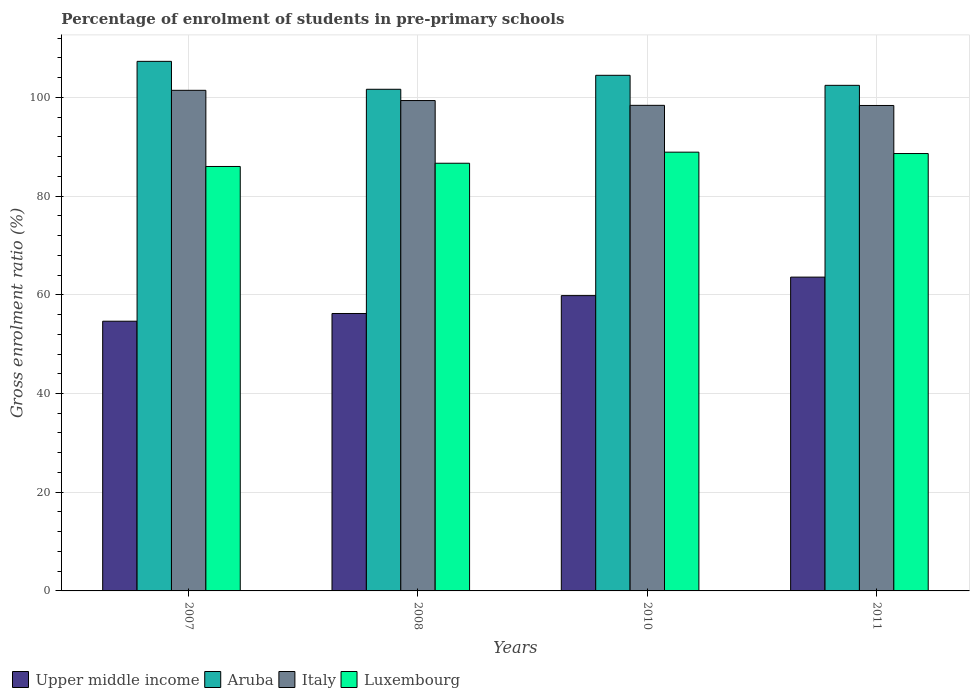Are the number of bars on each tick of the X-axis equal?
Provide a succinct answer. Yes. How many bars are there on the 2nd tick from the left?
Your answer should be very brief. 4. How many bars are there on the 4th tick from the right?
Your answer should be very brief. 4. What is the label of the 3rd group of bars from the left?
Provide a succinct answer. 2010. What is the percentage of students enrolled in pre-primary schools in Italy in 2008?
Give a very brief answer. 99.35. Across all years, what is the maximum percentage of students enrolled in pre-primary schools in Italy?
Offer a terse response. 101.42. Across all years, what is the minimum percentage of students enrolled in pre-primary schools in Upper middle income?
Provide a succinct answer. 54.64. What is the total percentage of students enrolled in pre-primary schools in Italy in the graph?
Your answer should be very brief. 397.5. What is the difference between the percentage of students enrolled in pre-primary schools in Luxembourg in 2008 and that in 2010?
Your response must be concise. -2.25. What is the difference between the percentage of students enrolled in pre-primary schools in Upper middle income in 2008 and the percentage of students enrolled in pre-primary schools in Aruba in 2007?
Provide a short and direct response. -51.08. What is the average percentage of students enrolled in pre-primary schools in Italy per year?
Offer a very short reply. 99.38. In the year 2010, what is the difference between the percentage of students enrolled in pre-primary schools in Italy and percentage of students enrolled in pre-primary schools in Luxembourg?
Make the answer very short. 9.49. In how many years, is the percentage of students enrolled in pre-primary schools in Italy greater than 24 %?
Your answer should be very brief. 4. What is the ratio of the percentage of students enrolled in pre-primary schools in Upper middle income in 2010 to that in 2011?
Provide a short and direct response. 0.94. What is the difference between the highest and the second highest percentage of students enrolled in pre-primary schools in Luxembourg?
Keep it short and to the point. 0.28. What is the difference between the highest and the lowest percentage of students enrolled in pre-primary schools in Italy?
Ensure brevity in your answer.  3.07. In how many years, is the percentage of students enrolled in pre-primary schools in Luxembourg greater than the average percentage of students enrolled in pre-primary schools in Luxembourg taken over all years?
Ensure brevity in your answer.  2. Is it the case that in every year, the sum of the percentage of students enrolled in pre-primary schools in Aruba and percentage of students enrolled in pre-primary schools in Italy is greater than the sum of percentage of students enrolled in pre-primary schools in Luxembourg and percentage of students enrolled in pre-primary schools in Upper middle income?
Keep it short and to the point. Yes. What does the 2nd bar from the left in 2010 represents?
Your answer should be very brief. Aruba. What does the 3rd bar from the right in 2008 represents?
Offer a terse response. Aruba. Is it the case that in every year, the sum of the percentage of students enrolled in pre-primary schools in Aruba and percentage of students enrolled in pre-primary schools in Italy is greater than the percentage of students enrolled in pre-primary schools in Luxembourg?
Your response must be concise. Yes. Are the values on the major ticks of Y-axis written in scientific E-notation?
Offer a very short reply. No. Does the graph contain grids?
Your response must be concise. Yes. How many legend labels are there?
Provide a short and direct response. 4. How are the legend labels stacked?
Your response must be concise. Horizontal. What is the title of the graph?
Give a very brief answer. Percentage of enrolment of students in pre-primary schools. What is the label or title of the X-axis?
Your answer should be very brief. Years. What is the Gross enrolment ratio (%) in Upper middle income in 2007?
Provide a succinct answer. 54.64. What is the Gross enrolment ratio (%) of Aruba in 2007?
Make the answer very short. 107.29. What is the Gross enrolment ratio (%) of Italy in 2007?
Your response must be concise. 101.42. What is the Gross enrolment ratio (%) of Luxembourg in 2007?
Your answer should be compact. 85.99. What is the Gross enrolment ratio (%) in Upper middle income in 2008?
Keep it short and to the point. 56.21. What is the Gross enrolment ratio (%) of Aruba in 2008?
Ensure brevity in your answer.  101.63. What is the Gross enrolment ratio (%) of Italy in 2008?
Provide a succinct answer. 99.35. What is the Gross enrolment ratio (%) in Luxembourg in 2008?
Provide a succinct answer. 86.65. What is the Gross enrolment ratio (%) in Upper middle income in 2010?
Give a very brief answer. 59.83. What is the Gross enrolment ratio (%) in Aruba in 2010?
Your response must be concise. 104.46. What is the Gross enrolment ratio (%) of Italy in 2010?
Your response must be concise. 98.38. What is the Gross enrolment ratio (%) of Luxembourg in 2010?
Your answer should be compact. 88.89. What is the Gross enrolment ratio (%) of Upper middle income in 2011?
Your response must be concise. 63.58. What is the Gross enrolment ratio (%) in Aruba in 2011?
Give a very brief answer. 102.43. What is the Gross enrolment ratio (%) in Italy in 2011?
Ensure brevity in your answer.  98.35. What is the Gross enrolment ratio (%) in Luxembourg in 2011?
Offer a terse response. 88.61. Across all years, what is the maximum Gross enrolment ratio (%) of Upper middle income?
Give a very brief answer. 63.58. Across all years, what is the maximum Gross enrolment ratio (%) of Aruba?
Make the answer very short. 107.29. Across all years, what is the maximum Gross enrolment ratio (%) in Italy?
Offer a terse response. 101.42. Across all years, what is the maximum Gross enrolment ratio (%) of Luxembourg?
Your answer should be compact. 88.89. Across all years, what is the minimum Gross enrolment ratio (%) in Upper middle income?
Offer a very short reply. 54.64. Across all years, what is the minimum Gross enrolment ratio (%) in Aruba?
Your response must be concise. 101.63. Across all years, what is the minimum Gross enrolment ratio (%) of Italy?
Offer a terse response. 98.35. Across all years, what is the minimum Gross enrolment ratio (%) in Luxembourg?
Give a very brief answer. 85.99. What is the total Gross enrolment ratio (%) of Upper middle income in the graph?
Give a very brief answer. 234.26. What is the total Gross enrolment ratio (%) in Aruba in the graph?
Offer a very short reply. 415.81. What is the total Gross enrolment ratio (%) of Italy in the graph?
Provide a succinct answer. 397.5. What is the total Gross enrolment ratio (%) of Luxembourg in the graph?
Offer a very short reply. 350.15. What is the difference between the Gross enrolment ratio (%) in Upper middle income in 2007 and that in 2008?
Give a very brief answer. -1.57. What is the difference between the Gross enrolment ratio (%) in Aruba in 2007 and that in 2008?
Provide a succinct answer. 5.66. What is the difference between the Gross enrolment ratio (%) in Italy in 2007 and that in 2008?
Your response must be concise. 2.07. What is the difference between the Gross enrolment ratio (%) in Luxembourg in 2007 and that in 2008?
Offer a terse response. -0.65. What is the difference between the Gross enrolment ratio (%) in Upper middle income in 2007 and that in 2010?
Provide a short and direct response. -5.19. What is the difference between the Gross enrolment ratio (%) of Aruba in 2007 and that in 2010?
Provide a succinct answer. 2.83. What is the difference between the Gross enrolment ratio (%) of Italy in 2007 and that in 2010?
Keep it short and to the point. 3.04. What is the difference between the Gross enrolment ratio (%) in Luxembourg in 2007 and that in 2010?
Your response must be concise. -2.9. What is the difference between the Gross enrolment ratio (%) in Upper middle income in 2007 and that in 2011?
Offer a terse response. -8.93. What is the difference between the Gross enrolment ratio (%) of Aruba in 2007 and that in 2011?
Your answer should be very brief. 4.86. What is the difference between the Gross enrolment ratio (%) in Italy in 2007 and that in 2011?
Give a very brief answer. 3.07. What is the difference between the Gross enrolment ratio (%) in Luxembourg in 2007 and that in 2011?
Provide a short and direct response. -2.62. What is the difference between the Gross enrolment ratio (%) in Upper middle income in 2008 and that in 2010?
Your answer should be compact. -3.62. What is the difference between the Gross enrolment ratio (%) of Aruba in 2008 and that in 2010?
Offer a very short reply. -2.83. What is the difference between the Gross enrolment ratio (%) of Italy in 2008 and that in 2010?
Provide a short and direct response. 0.97. What is the difference between the Gross enrolment ratio (%) of Luxembourg in 2008 and that in 2010?
Ensure brevity in your answer.  -2.25. What is the difference between the Gross enrolment ratio (%) in Upper middle income in 2008 and that in 2011?
Give a very brief answer. -7.37. What is the difference between the Gross enrolment ratio (%) of Aruba in 2008 and that in 2011?
Make the answer very short. -0.8. What is the difference between the Gross enrolment ratio (%) of Italy in 2008 and that in 2011?
Offer a terse response. 1. What is the difference between the Gross enrolment ratio (%) of Luxembourg in 2008 and that in 2011?
Ensure brevity in your answer.  -1.97. What is the difference between the Gross enrolment ratio (%) in Upper middle income in 2010 and that in 2011?
Provide a short and direct response. -3.75. What is the difference between the Gross enrolment ratio (%) in Aruba in 2010 and that in 2011?
Give a very brief answer. 2.03. What is the difference between the Gross enrolment ratio (%) in Italy in 2010 and that in 2011?
Provide a short and direct response. 0.03. What is the difference between the Gross enrolment ratio (%) in Luxembourg in 2010 and that in 2011?
Provide a succinct answer. 0.28. What is the difference between the Gross enrolment ratio (%) of Upper middle income in 2007 and the Gross enrolment ratio (%) of Aruba in 2008?
Keep it short and to the point. -46.99. What is the difference between the Gross enrolment ratio (%) in Upper middle income in 2007 and the Gross enrolment ratio (%) in Italy in 2008?
Provide a short and direct response. -44.71. What is the difference between the Gross enrolment ratio (%) in Upper middle income in 2007 and the Gross enrolment ratio (%) in Luxembourg in 2008?
Offer a very short reply. -32.01. What is the difference between the Gross enrolment ratio (%) of Aruba in 2007 and the Gross enrolment ratio (%) of Italy in 2008?
Your answer should be compact. 7.94. What is the difference between the Gross enrolment ratio (%) of Aruba in 2007 and the Gross enrolment ratio (%) of Luxembourg in 2008?
Provide a short and direct response. 20.64. What is the difference between the Gross enrolment ratio (%) of Italy in 2007 and the Gross enrolment ratio (%) of Luxembourg in 2008?
Your answer should be very brief. 14.77. What is the difference between the Gross enrolment ratio (%) in Upper middle income in 2007 and the Gross enrolment ratio (%) in Aruba in 2010?
Provide a succinct answer. -49.82. What is the difference between the Gross enrolment ratio (%) in Upper middle income in 2007 and the Gross enrolment ratio (%) in Italy in 2010?
Offer a terse response. -43.74. What is the difference between the Gross enrolment ratio (%) of Upper middle income in 2007 and the Gross enrolment ratio (%) of Luxembourg in 2010?
Give a very brief answer. -34.25. What is the difference between the Gross enrolment ratio (%) of Aruba in 2007 and the Gross enrolment ratio (%) of Italy in 2010?
Make the answer very short. 8.91. What is the difference between the Gross enrolment ratio (%) in Aruba in 2007 and the Gross enrolment ratio (%) in Luxembourg in 2010?
Offer a terse response. 18.4. What is the difference between the Gross enrolment ratio (%) of Italy in 2007 and the Gross enrolment ratio (%) of Luxembourg in 2010?
Offer a very short reply. 12.53. What is the difference between the Gross enrolment ratio (%) of Upper middle income in 2007 and the Gross enrolment ratio (%) of Aruba in 2011?
Make the answer very short. -47.79. What is the difference between the Gross enrolment ratio (%) of Upper middle income in 2007 and the Gross enrolment ratio (%) of Italy in 2011?
Provide a succinct answer. -43.71. What is the difference between the Gross enrolment ratio (%) of Upper middle income in 2007 and the Gross enrolment ratio (%) of Luxembourg in 2011?
Provide a short and direct response. -33.97. What is the difference between the Gross enrolment ratio (%) in Aruba in 2007 and the Gross enrolment ratio (%) in Italy in 2011?
Offer a very short reply. 8.94. What is the difference between the Gross enrolment ratio (%) in Aruba in 2007 and the Gross enrolment ratio (%) in Luxembourg in 2011?
Provide a short and direct response. 18.68. What is the difference between the Gross enrolment ratio (%) in Italy in 2007 and the Gross enrolment ratio (%) in Luxembourg in 2011?
Keep it short and to the point. 12.81. What is the difference between the Gross enrolment ratio (%) in Upper middle income in 2008 and the Gross enrolment ratio (%) in Aruba in 2010?
Your answer should be very brief. -48.25. What is the difference between the Gross enrolment ratio (%) of Upper middle income in 2008 and the Gross enrolment ratio (%) of Italy in 2010?
Provide a short and direct response. -42.17. What is the difference between the Gross enrolment ratio (%) of Upper middle income in 2008 and the Gross enrolment ratio (%) of Luxembourg in 2010?
Provide a succinct answer. -32.69. What is the difference between the Gross enrolment ratio (%) in Aruba in 2008 and the Gross enrolment ratio (%) in Italy in 2010?
Your answer should be very brief. 3.25. What is the difference between the Gross enrolment ratio (%) of Aruba in 2008 and the Gross enrolment ratio (%) of Luxembourg in 2010?
Provide a short and direct response. 12.74. What is the difference between the Gross enrolment ratio (%) in Italy in 2008 and the Gross enrolment ratio (%) in Luxembourg in 2010?
Ensure brevity in your answer.  10.46. What is the difference between the Gross enrolment ratio (%) in Upper middle income in 2008 and the Gross enrolment ratio (%) in Aruba in 2011?
Your answer should be compact. -46.22. What is the difference between the Gross enrolment ratio (%) of Upper middle income in 2008 and the Gross enrolment ratio (%) of Italy in 2011?
Ensure brevity in your answer.  -42.14. What is the difference between the Gross enrolment ratio (%) in Upper middle income in 2008 and the Gross enrolment ratio (%) in Luxembourg in 2011?
Give a very brief answer. -32.4. What is the difference between the Gross enrolment ratio (%) in Aruba in 2008 and the Gross enrolment ratio (%) in Italy in 2011?
Keep it short and to the point. 3.28. What is the difference between the Gross enrolment ratio (%) of Aruba in 2008 and the Gross enrolment ratio (%) of Luxembourg in 2011?
Your answer should be very brief. 13.02. What is the difference between the Gross enrolment ratio (%) of Italy in 2008 and the Gross enrolment ratio (%) of Luxembourg in 2011?
Offer a very short reply. 10.74. What is the difference between the Gross enrolment ratio (%) of Upper middle income in 2010 and the Gross enrolment ratio (%) of Aruba in 2011?
Give a very brief answer. -42.6. What is the difference between the Gross enrolment ratio (%) of Upper middle income in 2010 and the Gross enrolment ratio (%) of Italy in 2011?
Provide a short and direct response. -38.52. What is the difference between the Gross enrolment ratio (%) of Upper middle income in 2010 and the Gross enrolment ratio (%) of Luxembourg in 2011?
Your answer should be compact. -28.78. What is the difference between the Gross enrolment ratio (%) in Aruba in 2010 and the Gross enrolment ratio (%) in Italy in 2011?
Your response must be concise. 6.11. What is the difference between the Gross enrolment ratio (%) of Aruba in 2010 and the Gross enrolment ratio (%) of Luxembourg in 2011?
Give a very brief answer. 15.85. What is the difference between the Gross enrolment ratio (%) of Italy in 2010 and the Gross enrolment ratio (%) of Luxembourg in 2011?
Provide a short and direct response. 9.77. What is the average Gross enrolment ratio (%) in Upper middle income per year?
Make the answer very short. 58.56. What is the average Gross enrolment ratio (%) of Aruba per year?
Ensure brevity in your answer.  103.95. What is the average Gross enrolment ratio (%) of Italy per year?
Your response must be concise. 99.38. What is the average Gross enrolment ratio (%) in Luxembourg per year?
Offer a very short reply. 87.54. In the year 2007, what is the difference between the Gross enrolment ratio (%) of Upper middle income and Gross enrolment ratio (%) of Aruba?
Ensure brevity in your answer.  -52.65. In the year 2007, what is the difference between the Gross enrolment ratio (%) of Upper middle income and Gross enrolment ratio (%) of Italy?
Your response must be concise. -46.78. In the year 2007, what is the difference between the Gross enrolment ratio (%) in Upper middle income and Gross enrolment ratio (%) in Luxembourg?
Your answer should be compact. -31.35. In the year 2007, what is the difference between the Gross enrolment ratio (%) of Aruba and Gross enrolment ratio (%) of Italy?
Provide a succinct answer. 5.87. In the year 2007, what is the difference between the Gross enrolment ratio (%) in Aruba and Gross enrolment ratio (%) in Luxembourg?
Your answer should be compact. 21.3. In the year 2007, what is the difference between the Gross enrolment ratio (%) of Italy and Gross enrolment ratio (%) of Luxembourg?
Ensure brevity in your answer.  15.43. In the year 2008, what is the difference between the Gross enrolment ratio (%) in Upper middle income and Gross enrolment ratio (%) in Aruba?
Keep it short and to the point. -45.42. In the year 2008, what is the difference between the Gross enrolment ratio (%) of Upper middle income and Gross enrolment ratio (%) of Italy?
Keep it short and to the point. -43.14. In the year 2008, what is the difference between the Gross enrolment ratio (%) of Upper middle income and Gross enrolment ratio (%) of Luxembourg?
Your response must be concise. -30.44. In the year 2008, what is the difference between the Gross enrolment ratio (%) in Aruba and Gross enrolment ratio (%) in Italy?
Offer a very short reply. 2.28. In the year 2008, what is the difference between the Gross enrolment ratio (%) in Aruba and Gross enrolment ratio (%) in Luxembourg?
Your answer should be compact. 14.98. In the year 2008, what is the difference between the Gross enrolment ratio (%) in Italy and Gross enrolment ratio (%) in Luxembourg?
Provide a succinct answer. 12.7. In the year 2010, what is the difference between the Gross enrolment ratio (%) in Upper middle income and Gross enrolment ratio (%) in Aruba?
Your answer should be very brief. -44.63. In the year 2010, what is the difference between the Gross enrolment ratio (%) of Upper middle income and Gross enrolment ratio (%) of Italy?
Your response must be concise. -38.55. In the year 2010, what is the difference between the Gross enrolment ratio (%) in Upper middle income and Gross enrolment ratio (%) in Luxembourg?
Make the answer very short. -29.06. In the year 2010, what is the difference between the Gross enrolment ratio (%) in Aruba and Gross enrolment ratio (%) in Italy?
Give a very brief answer. 6.08. In the year 2010, what is the difference between the Gross enrolment ratio (%) of Aruba and Gross enrolment ratio (%) of Luxembourg?
Your answer should be compact. 15.57. In the year 2010, what is the difference between the Gross enrolment ratio (%) of Italy and Gross enrolment ratio (%) of Luxembourg?
Give a very brief answer. 9.49. In the year 2011, what is the difference between the Gross enrolment ratio (%) in Upper middle income and Gross enrolment ratio (%) in Aruba?
Make the answer very short. -38.85. In the year 2011, what is the difference between the Gross enrolment ratio (%) of Upper middle income and Gross enrolment ratio (%) of Italy?
Your answer should be very brief. -34.78. In the year 2011, what is the difference between the Gross enrolment ratio (%) in Upper middle income and Gross enrolment ratio (%) in Luxembourg?
Your response must be concise. -25.04. In the year 2011, what is the difference between the Gross enrolment ratio (%) of Aruba and Gross enrolment ratio (%) of Italy?
Your response must be concise. 4.08. In the year 2011, what is the difference between the Gross enrolment ratio (%) in Aruba and Gross enrolment ratio (%) in Luxembourg?
Make the answer very short. 13.82. In the year 2011, what is the difference between the Gross enrolment ratio (%) of Italy and Gross enrolment ratio (%) of Luxembourg?
Offer a very short reply. 9.74. What is the ratio of the Gross enrolment ratio (%) in Upper middle income in 2007 to that in 2008?
Offer a very short reply. 0.97. What is the ratio of the Gross enrolment ratio (%) in Aruba in 2007 to that in 2008?
Your response must be concise. 1.06. What is the ratio of the Gross enrolment ratio (%) in Italy in 2007 to that in 2008?
Your response must be concise. 1.02. What is the ratio of the Gross enrolment ratio (%) of Upper middle income in 2007 to that in 2010?
Make the answer very short. 0.91. What is the ratio of the Gross enrolment ratio (%) in Aruba in 2007 to that in 2010?
Your answer should be compact. 1.03. What is the ratio of the Gross enrolment ratio (%) in Italy in 2007 to that in 2010?
Offer a very short reply. 1.03. What is the ratio of the Gross enrolment ratio (%) in Luxembourg in 2007 to that in 2010?
Give a very brief answer. 0.97. What is the ratio of the Gross enrolment ratio (%) of Upper middle income in 2007 to that in 2011?
Provide a short and direct response. 0.86. What is the ratio of the Gross enrolment ratio (%) of Aruba in 2007 to that in 2011?
Give a very brief answer. 1.05. What is the ratio of the Gross enrolment ratio (%) of Italy in 2007 to that in 2011?
Give a very brief answer. 1.03. What is the ratio of the Gross enrolment ratio (%) of Luxembourg in 2007 to that in 2011?
Provide a succinct answer. 0.97. What is the ratio of the Gross enrolment ratio (%) in Upper middle income in 2008 to that in 2010?
Keep it short and to the point. 0.94. What is the ratio of the Gross enrolment ratio (%) of Aruba in 2008 to that in 2010?
Offer a very short reply. 0.97. What is the ratio of the Gross enrolment ratio (%) in Italy in 2008 to that in 2010?
Ensure brevity in your answer.  1.01. What is the ratio of the Gross enrolment ratio (%) in Luxembourg in 2008 to that in 2010?
Ensure brevity in your answer.  0.97. What is the ratio of the Gross enrolment ratio (%) in Upper middle income in 2008 to that in 2011?
Provide a succinct answer. 0.88. What is the ratio of the Gross enrolment ratio (%) of Aruba in 2008 to that in 2011?
Your response must be concise. 0.99. What is the ratio of the Gross enrolment ratio (%) of Luxembourg in 2008 to that in 2011?
Offer a terse response. 0.98. What is the ratio of the Gross enrolment ratio (%) of Upper middle income in 2010 to that in 2011?
Make the answer very short. 0.94. What is the ratio of the Gross enrolment ratio (%) in Aruba in 2010 to that in 2011?
Ensure brevity in your answer.  1.02. What is the ratio of the Gross enrolment ratio (%) of Luxembourg in 2010 to that in 2011?
Give a very brief answer. 1. What is the difference between the highest and the second highest Gross enrolment ratio (%) of Upper middle income?
Keep it short and to the point. 3.75. What is the difference between the highest and the second highest Gross enrolment ratio (%) in Aruba?
Provide a short and direct response. 2.83. What is the difference between the highest and the second highest Gross enrolment ratio (%) in Italy?
Provide a succinct answer. 2.07. What is the difference between the highest and the second highest Gross enrolment ratio (%) of Luxembourg?
Your answer should be very brief. 0.28. What is the difference between the highest and the lowest Gross enrolment ratio (%) in Upper middle income?
Provide a succinct answer. 8.93. What is the difference between the highest and the lowest Gross enrolment ratio (%) of Aruba?
Ensure brevity in your answer.  5.66. What is the difference between the highest and the lowest Gross enrolment ratio (%) in Italy?
Offer a terse response. 3.07. What is the difference between the highest and the lowest Gross enrolment ratio (%) of Luxembourg?
Offer a very short reply. 2.9. 